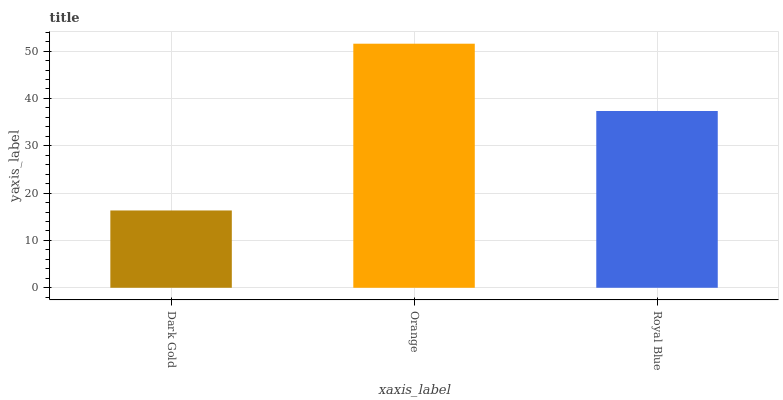Is Dark Gold the minimum?
Answer yes or no. Yes. Is Orange the maximum?
Answer yes or no. Yes. Is Royal Blue the minimum?
Answer yes or no. No. Is Royal Blue the maximum?
Answer yes or no. No. Is Orange greater than Royal Blue?
Answer yes or no. Yes. Is Royal Blue less than Orange?
Answer yes or no. Yes. Is Royal Blue greater than Orange?
Answer yes or no. No. Is Orange less than Royal Blue?
Answer yes or no. No. Is Royal Blue the high median?
Answer yes or no. Yes. Is Royal Blue the low median?
Answer yes or no. Yes. Is Dark Gold the high median?
Answer yes or no. No. Is Orange the low median?
Answer yes or no. No. 